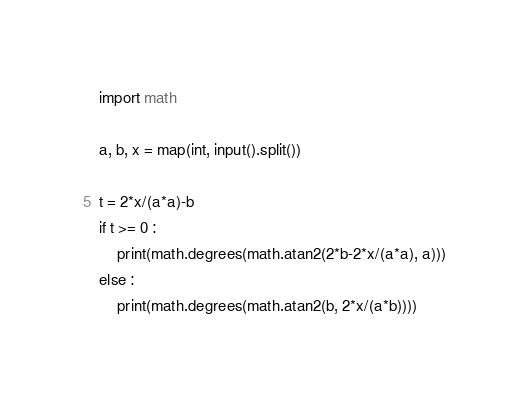Convert code to text. <code><loc_0><loc_0><loc_500><loc_500><_Python_>import math

a, b, x = map(int, input().split())

t = 2*x/(a*a)-b
if t >= 0 :
    print(math.degrees(math.atan2(2*b-2*x/(a*a), a)))
else :
    print(math.degrees(math.atan2(b, 2*x/(a*b))))</code> 